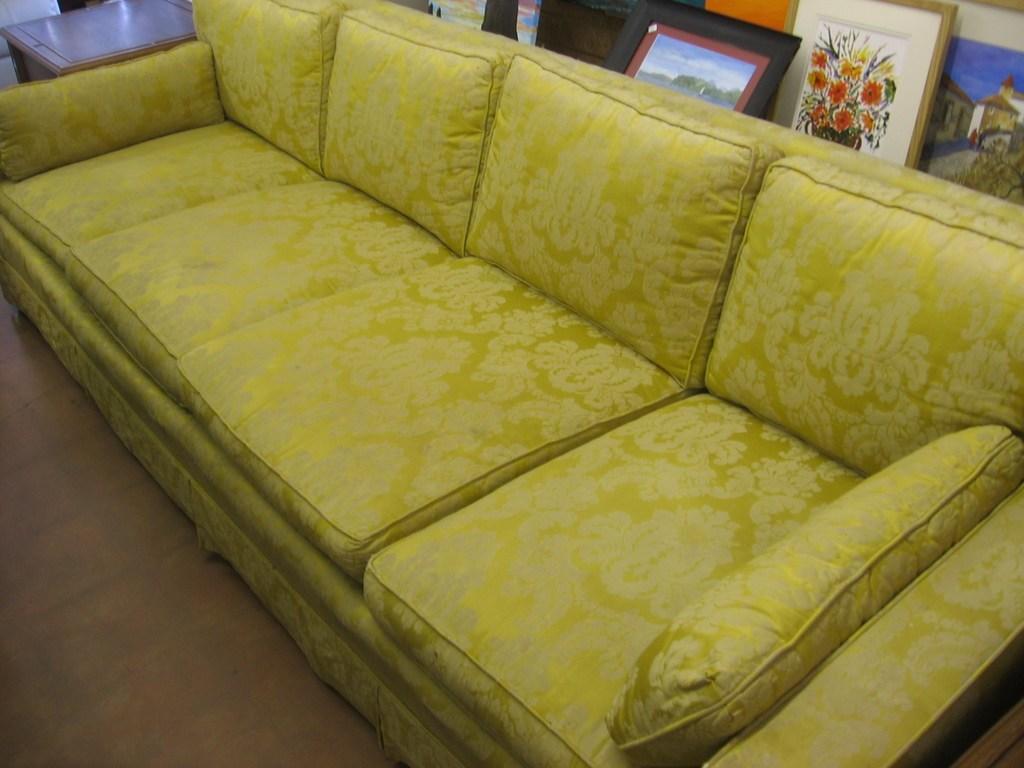In one or two sentences, can you explain what this image depicts? In the image we can see there is a sofa which is in yellow colour. 